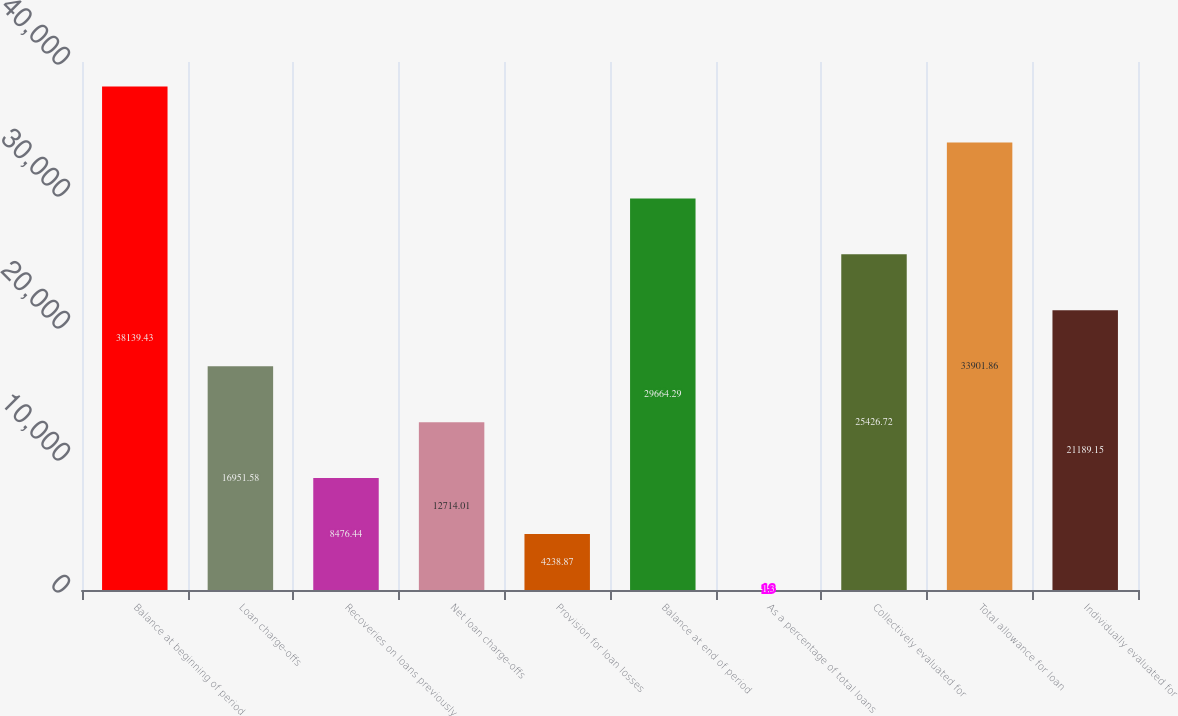<chart> <loc_0><loc_0><loc_500><loc_500><bar_chart><fcel>Balance at beginning of period<fcel>Loan charge-offs<fcel>Recoveries on loans previously<fcel>Net loan charge-offs<fcel>Provision for loan losses<fcel>Balance at end of period<fcel>As a percentage of total loans<fcel>Collectively evaluated for<fcel>Total allowance for loan<fcel>Individually evaluated for<nl><fcel>38139.4<fcel>16951.6<fcel>8476.44<fcel>12714<fcel>4238.87<fcel>29664.3<fcel>1.3<fcel>25426.7<fcel>33901.9<fcel>21189.2<nl></chart> 